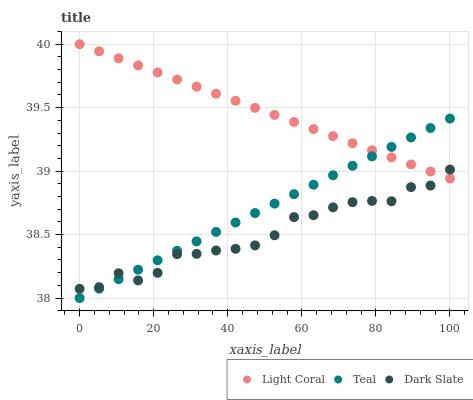Does Dark Slate have the minimum area under the curve?
Answer yes or no. Yes. Does Light Coral have the maximum area under the curve?
Answer yes or no. Yes. Does Teal have the minimum area under the curve?
Answer yes or no. No. Does Teal have the maximum area under the curve?
Answer yes or no. No. Is Light Coral the smoothest?
Answer yes or no. Yes. Is Dark Slate the roughest?
Answer yes or no. Yes. Is Teal the smoothest?
Answer yes or no. No. Is Teal the roughest?
Answer yes or no. No. Does Teal have the lowest value?
Answer yes or no. Yes. Does Dark Slate have the lowest value?
Answer yes or no. No. Does Light Coral have the highest value?
Answer yes or no. Yes. Does Teal have the highest value?
Answer yes or no. No. Does Dark Slate intersect Light Coral?
Answer yes or no. Yes. Is Dark Slate less than Light Coral?
Answer yes or no. No. Is Dark Slate greater than Light Coral?
Answer yes or no. No. 